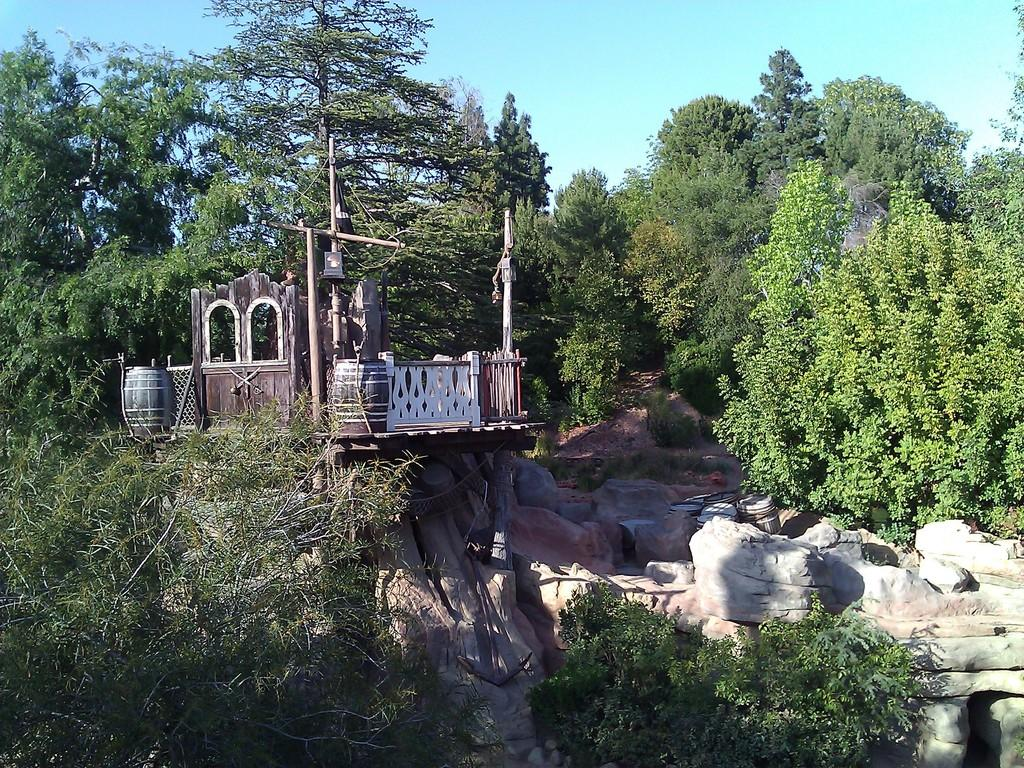What type of structure is visible in the image? There is a wooden construction in the image. Where is the wooden construction located? The wooden construction is on a rock. What is the surrounding environment of the wooden construction? The wooden construction is surrounded by trees and rocks. Can you see a nest in the wooden construction? There is no nest visible in the wooden construction or the image. 